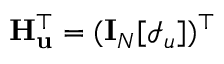<formula> <loc_0><loc_0><loc_500><loc_500>H _ { u } ^ { \top } = ( I _ { N } [ \mathcal { I } _ { u } ] ) ^ { \top }</formula> 